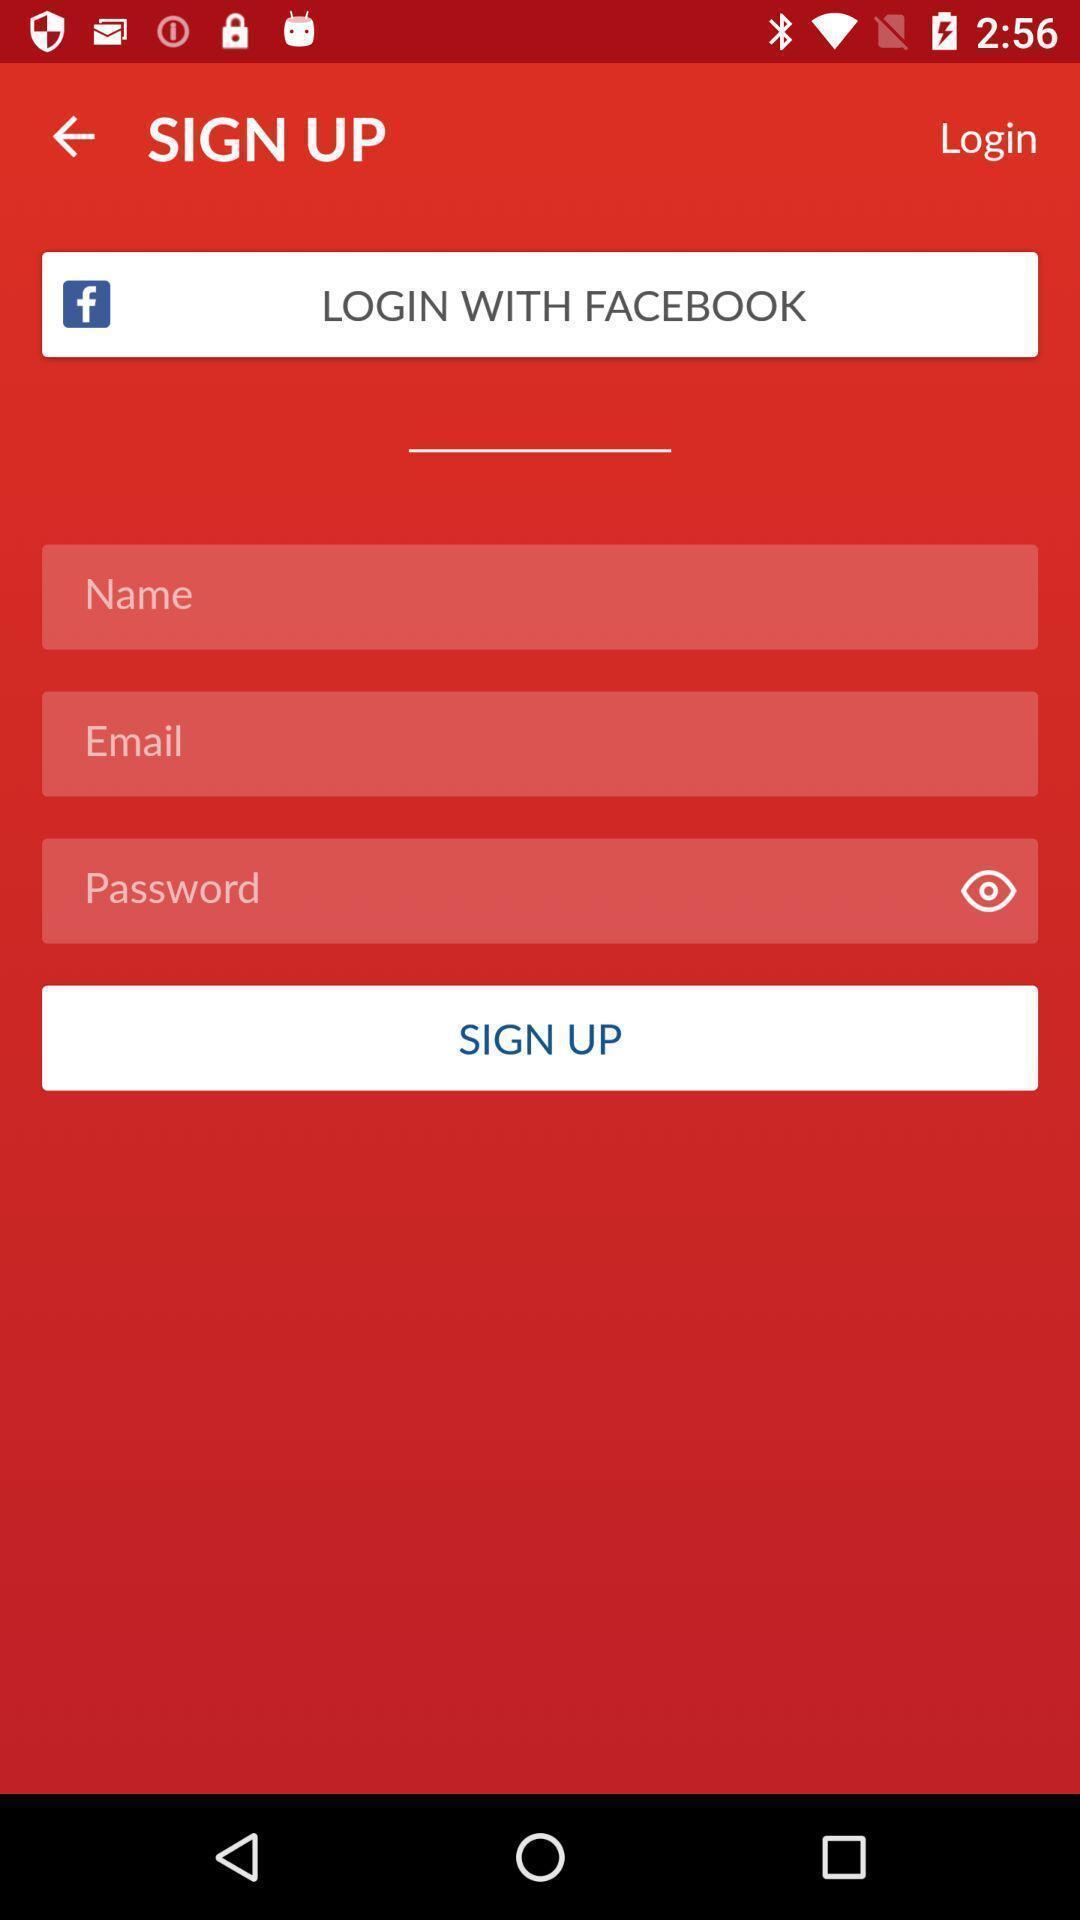Give me a narrative description of this picture. Sign up page with credentials to enter. 